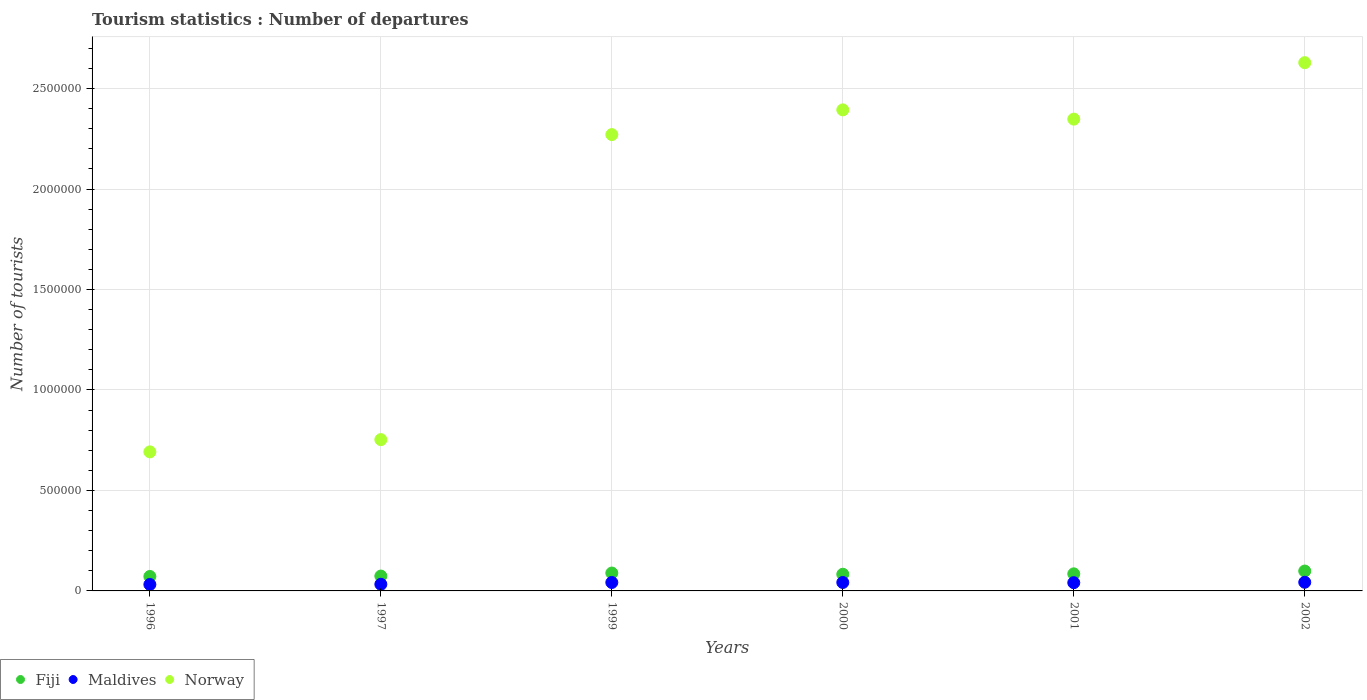Is the number of dotlines equal to the number of legend labels?
Give a very brief answer. Yes. What is the number of tourist departures in Maldives in 2000?
Make the answer very short. 4.20e+04. Across all years, what is the maximum number of tourist departures in Maldives?
Offer a terse response. 4.30e+04. Across all years, what is the minimum number of tourist departures in Norway?
Provide a short and direct response. 6.92e+05. What is the total number of tourist departures in Fiji in the graph?
Make the answer very short. 5.02e+05. What is the difference between the number of tourist departures in Maldives in 1996 and that in 2002?
Your answer should be very brief. -1.10e+04. What is the difference between the number of tourist departures in Fiji in 1999 and the number of tourist departures in Maldives in 2000?
Make the answer very short. 4.70e+04. What is the average number of tourist departures in Maldives per year?
Give a very brief answer. 3.88e+04. In the year 2002, what is the difference between the number of tourist departures in Fiji and number of tourist departures in Norway?
Ensure brevity in your answer.  -2.53e+06. What is the ratio of the number of tourist departures in Norway in 1997 to that in 2000?
Provide a short and direct response. 0.31. Is the difference between the number of tourist departures in Fiji in 1999 and 2002 greater than the difference between the number of tourist departures in Norway in 1999 and 2002?
Your answer should be very brief. Yes. What is the difference between the highest and the lowest number of tourist departures in Maldives?
Offer a very short reply. 1.10e+04. Is it the case that in every year, the sum of the number of tourist departures in Maldives and number of tourist departures in Fiji  is greater than the number of tourist departures in Norway?
Your answer should be compact. No. Is the number of tourist departures in Maldives strictly less than the number of tourist departures in Fiji over the years?
Your response must be concise. Yes. How many dotlines are there?
Offer a very short reply. 3. How many years are there in the graph?
Give a very brief answer. 6. Does the graph contain grids?
Your response must be concise. Yes. What is the title of the graph?
Provide a short and direct response. Tourism statistics : Number of departures. What is the label or title of the Y-axis?
Your response must be concise. Number of tourists. What is the Number of tourists in Fiji in 1996?
Offer a very short reply. 7.20e+04. What is the Number of tourists of Maldives in 1996?
Keep it short and to the point. 3.20e+04. What is the Number of tourists of Norway in 1996?
Provide a short and direct response. 6.92e+05. What is the Number of tourists of Fiji in 1997?
Offer a terse response. 7.40e+04. What is the Number of tourists of Maldives in 1997?
Your response must be concise. 3.30e+04. What is the Number of tourists in Norway in 1997?
Provide a short and direct response. 7.53e+05. What is the Number of tourists in Fiji in 1999?
Provide a succinct answer. 8.90e+04. What is the Number of tourists of Maldives in 1999?
Your answer should be very brief. 4.20e+04. What is the Number of tourists in Norway in 1999?
Make the answer very short. 2.27e+06. What is the Number of tourists in Fiji in 2000?
Provide a short and direct response. 8.30e+04. What is the Number of tourists of Maldives in 2000?
Make the answer very short. 4.20e+04. What is the Number of tourists of Norway in 2000?
Offer a very short reply. 2.39e+06. What is the Number of tourists in Fiji in 2001?
Ensure brevity in your answer.  8.50e+04. What is the Number of tourists in Maldives in 2001?
Ensure brevity in your answer.  4.10e+04. What is the Number of tourists in Norway in 2001?
Your response must be concise. 2.35e+06. What is the Number of tourists in Fiji in 2002?
Make the answer very short. 9.90e+04. What is the Number of tourists of Maldives in 2002?
Offer a very short reply. 4.30e+04. What is the Number of tourists in Norway in 2002?
Your answer should be very brief. 2.63e+06. Across all years, what is the maximum Number of tourists in Fiji?
Provide a succinct answer. 9.90e+04. Across all years, what is the maximum Number of tourists of Maldives?
Keep it short and to the point. 4.30e+04. Across all years, what is the maximum Number of tourists of Norway?
Keep it short and to the point. 2.63e+06. Across all years, what is the minimum Number of tourists in Fiji?
Your answer should be very brief. 7.20e+04. Across all years, what is the minimum Number of tourists of Maldives?
Give a very brief answer. 3.20e+04. Across all years, what is the minimum Number of tourists of Norway?
Provide a succinct answer. 6.92e+05. What is the total Number of tourists in Fiji in the graph?
Keep it short and to the point. 5.02e+05. What is the total Number of tourists in Maldives in the graph?
Ensure brevity in your answer.  2.33e+05. What is the total Number of tourists in Norway in the graph?
Keep it short and to the point. 1.11e+07. What is the difference between the Number of tourists of Fiji in 1996 and that in 1997?
Your response must be concise. -2000. What is the difference between the Number of tourists in Maldives in 1996 and that in 1997?
Keep it short and to the point. -1000. What is the difference between the Number of tourists of Norway in 1996 and that in 1997?
Provide a short and direct response. -6.10e+04. What is the difference between the Number of tourists in Fiji in 1996 and that in 1999?
Offer a terse response. -1.70e+04. What is the difference between the Number of tourists of Maldives in 1996 and that in 1999?
Offer a terse response. -10000. What is the difference between the Number of tourists in Norway in 1996 and that in 1999?
Your answer should be very brief. -1.58e+06. What is the difference between the Number of tourists in Fiji in 1996 and that in 2000?
Your response must be concise. -1.10e+04. What is the difference between the Number of tourists of Norway in 1996 and that in 2000?
Keep it short and to the point. -1.70e+06. What is the difference between the Number of tourists of Fiji in 1996 and that in 2001?
Your answer should be compact. -1.30e+04. What is the difference between the Number of tourists of Maldives in 1996 and that in 2001?
Your answer should be compact. -9000. What is the difference between the Number of tourists of Norway in 1996 and that in 2001?
Offer a very short reply. -1.66e+06. What is the difference between the Number of tourists in Fiji in 1996 and that in 2002?
Your response must be concise. -2.70e+04. What is the difference between the Number of tourists of Maldives in 1996 and that in 2002?
Offer a very short reply. -1.10e+04. What is the difference between the Number of tourists of Norway in 1996 and that in 2002?
Provide a succinct answer. -1.94e+06. What is the difference between the Number of tourists in Fiji in 1997 and that in 1999?
Keep it short and to the point. -1.50e+04. What is the difference between the Number of tourists of Maldives in 1997 and that in 1999?
Offer a very short reply. -9000. What is the difference between the Number of tourists of Norway in 1997 and that in 1999?
Ensure brevity in your answer.  -1.52e+06. What is the difference between the Number of tourists of Fiji in 1997 and that in 2000?
Provide a succinct answer. -9000. What is the difference between the Number of tourists in Maldives in 1997 and that in 2000?
Provide a succinct answer. -9000. What is the difference between the Number of tourists in Norway in 1997 and that in 2000?
Provide a short and direct response. -1.64e+06. What is the difference between the Number of tourists in Fiji in 1997 and that in 2001?
Provide a succinct answer. -1.10e+04. What is the difference between the Number of tourists of Maldives in 1997 and that in 2001?
Offer a terse response. -8000. What is the difference between the Number of tourists of Norway in 1997 and that in 2001?
Give a very brief answer. -1.60e+06. What is the difference between the Number of tourists of Fiji in 1997 and that in 2002?
Provide a short and direct response. -2.50e+04. What is the difference between the Number of tourists in Norway in 1997 and that in 2002?
Ensure brevity in your answer.  -1.88e+06. What is the difference between the Number of tourists of Fiji in 1999 and that in 2000?
Make the answer very short. 6000. What is the difference between the Number of tourists of Maldives in 1999 and that in 2000?
Provide a short and direct response. 0. What is the difference between the Number of tourists in Norway in 1999 and that in 2000?
Your answer should be compact. -1.23e+05. What is the difference between the Number of tourists in Fiji in 1999 and that in 2001?
Ensure brevity in your answer.  4000. What is the difference between the Number of tourists of Maldives in 1999 and that in 2001?
Ensure brevity in your answer.  1000. What is the difference between the Number of tourists of Norway in 1999 and that in 2001?
Provide a succinct answer. -7.70e+04. What is the difference between the Number of tourists in Maldives in 1999 and that in 2002?
Provide a succinct answer. -1000. What is the difference between the Number of tourists in Norway in 1999 and that in 2002?
Provide a short and direct response. -3.58e+05. What is the difference between the Number of tourists of Fiji in 2000 and that in 2001?
Provide a succinct answer. -2000. What is the difference between the Number of tourists of Norway in 2000 and that in 2001?
Offer a terse response. 4.60e+04. What is the difference between the Number of tourists of Fiji in 2000 and that in 2002?
Keep it short and to the point. -1.60e+04. What is the difference between the Number of tourists in Maldives in 2000 and that in 2002?
Offer a terse response. -1000. What is the difference between the Number of tourists in Norway in 2000 and that in 2002?
Provide a succinct answer. -2.35e+05. What is the difference between the Number of tourists of Fiji in 2001 and that in 2002?
Keep it short and to the point. -1.40e+04. What is the difference between the Number of tourists in Maldives in 2001 and that in 2002?
Ensure brevity in your answer.  -2000. What is the difference between the Number of tourists of Norway in 2001 and that in 2002?
Provide a succinct answer. -2.81e+05. What is the difference between the Number of tourists in Fiji in 1996 and the Number of tourists in Maldives in 1997?
Your answer should be compact. 3.90e+04. What is the difference between the Number of tourists of Fiji in 1996 and the Number of tourists of Norway in 1997?
Your answer should be very brief. -6.81e+05. What is the difference between the Number of tourists in Maldives in 1996 and the Number of tourists in Norway in 1997?
Make the answer very short. -7.21e+05. What is the difference between the Number of tourists of Fiji in 1996 and the Number of tourists of Maldives in 1999?
Provide a short and direct response. 3.00e+04. What is the difference between the Number of tourists in Fiji in 1996 and the Number of tourists in Norway in 1999?
Provide a succinct answer. -2.20e+06. What is the difference between the Number of tourists of Maldives in 1996 and the Number of tourists of Norway in 1999?
Your response must be concise. -2.24e+06. What is the difference between the Number of tourists of Fiji in 1996 and the Number of tourists of Maldives in 2000?
Your response must be concise. 3.00e+04. What is the difference between the Number of tourists of Fiji in 1996 and the Number of tourists of Norway in 2000?
Your response must be concise. -2.32e+06. What is the difference between the Number of tourists in Maldives in 1996 and the Number of tourists in Norway in 2000?
Keep it short and to the point. -2.36e+06. What is the difference between the Number of tourists of Fiji in 1996 and the Number of tourists of Maldives in 2001?
Your response must be concise. 3.10e+04. What is the difference between the Number of tourists in Fiji in 1996 and the Number of tourists in Norway in 2001?
Keep it short and to the point. -2.28e+06. What is the difference between the Number of tourists of Maldives in 1996 and the Number of tourists of Norway in 2001?
Your response must be concise. -2.32e+06. What is the difference between the Number of tourists of Fiji in 1996 and the Number of tourists of Maldives in 2002?
Provide a succinct answer. 2.90e+04. What is the difference between the Number of tourists in Fiji in 1996 and the Number of tourists in Norway in 2002?
Offer a very short reply. -2.56e+06. What is the difference between the Number of tourists in Maldives in 1996 and the Number of tourists in Norway in 2002?
Your response must be concise. -2.60e+06. What is the difference between the Number of tourists in Fiji in 1997 and the Number of tourists in Maldives in 1999?
Your answer should be compact. 3.20e+04. What is the difference between the Number of tourists in Fiji in 1997 and the Number of tourists in Norway in 1999?
Keep it short and to the point. -2.20e+06. What is the difference between the Number of tourists in Maldives in 1997 and the Number of tourists in Norway in 1999?
Offer a terse response. -2.24e+06. What is the difference between the Number of tourists of Fiji in 1997 and the Number of tourists of Maldives in 2000?
Offer a terse response. 3.20e+04. What is the difference between the Number of tourists of Fiji in 1997 and the Number of tourists of Norway in 2000?
Provide a short and direct response. -2.32e+06. What is the difference between the Number of tourists of Maldives in 1997 and the Number of tourists of Norway in 2000?
Provide a short and direct response. -2.36e+06. What is the difference between the Number of tourists of Fiji in 1997 and the Number of tourists of Maldives in 2001?
Keep it short and to the point. 3.30e+04. What is the difference between the Number of tourists of Fiji in 1997 and the Number of tourists of Norway in 2001?
Your answer should be very brief. -2.27e+06. What is the difference between the Number of tourists of Maldives in 1997 and the Number of tourists of Norway in 2001?
Your answer should be compact. -2.32e+06. What is the difference between the Number of tourists in Fiji in 1997 and the Number of tourists in Maldives in 2002?
Your answer should be very brief. 3.10e+04. What is the difference between the Number of tourists in Fiji in 1997 and the Number of tourists in Norway in 2002?
Give a very brief answer. -2.56e+06. What is the difference between the Number of tourists in Maldives in 1997 and the Number of tourists in Norway in 2002?
Give a very brief answer. -2.60e+06. What is the difference between the Number of tourists in Fiji in 1999 and the Number of tourists in Maldives in 2000?
Ensure brevity in your answer.  4.70e+04. What is the difference between the Number of tourists of Fiji in 1999 and the Number of tourists of Norway in 2000?
Offer a very short reply. -2.30e+06. What is the difference between the Number of tourists of Maldives in 1999 and the Number of tourists of Norway in 2000?
Your response must be concise. -2.35e+06. What is the difference between the Number of tourists of Fiji in 1999 and the Number of tourists of Maldives in 2001?
Your answer should be very brief. 4.80e+04. What is the difference between the Number of tourists in Fiji in 1999 and the Number of tourists in Norway in 2001?
Provide a short and direct response. -2.26e+06. What is the difference between the Number of tourists of Maldives in 1999 and the Number of tourists of Norway in 2001?
Provide a short and direct response. -2.31e+06. What is the difference between the Number of tourists of Fiji in 1999 and the Number of tourists of Maldives in 2002?
Ensure brevity in your answer.  4.60e+04. What is the difference between the Number of tourists of Fiji in 1999 and the Number of tourists of Norway in 2002?
Keep it short and to the point. -2.54e+06. What is the difference between the Number of tourists of Maldives in 1999 and the Number of tourists of Norway in 2002?
Make the answer very short. -2.59e+06. What is the difference between the Number of tourists in Fiji in 2000 and the Number of tourists in Maldives in 2001?
Your answer should be very brief. 4.20e+04. What is the difference between the Number of tourists of Fiji in 2000 and the Number of tourists of Norway in 2001?
Keep it short and to the point. -2.26e+06. What is the difference between the Number of tourists of Maldives in 2000 and the Number of tourists of Norway in 2001?
Offer a very short reply. -2.31e+06. What is the difference between the Number of tourists in Fiji in 2000 and the Number of tourists in Maldives in 2002?
Keep it short and to the point. 4.00e+04. What is the difference between the Number of tourists of Fiji in 2000 and the Number of tourists of Norway in 2002?
Provide a short and direct response. -2.55e+06. What is the difference between the Number of tourists in Maldives in 2000 and the Number of tourists in Norway in 2002?
Offer a very short reply. -2.59e+06. What is the difference between the Number of tourists of Fiji in 2001 and the Number of tourists of Maldives in 2002?
Your response must be concise. 4.20e+04. What is the difference between the Number of tourists in Fiji in 2001 and the Number of tourists in Norway in 2002?
Offer a terse response. -2.54e+06. What is the difference between the Number of tourists in Maldives in 2001 and the Number of tourists in Norway in 2002?
Offer a very short reply. -2.59e+06. What is the average Number of tourists in Fiji per year?
Offer a terse response. 8.37e+04. What is the average Number of tourists in Maldives per year?
Provide a short and direct response. 3.88e+04. What is the average Number of tourists of Norway per year?
Your response must be concise. 1.85e+06. In the year 1996, what is the difference between the Number of tourists in Fiji and Number of tourists in Norway?
Provide a succinct answer. -6.20e+05. In the year 1996, what is the difference between the Number of tourists in Maldives and Number of tourists in Norway?
Offer a terse response. -6.60e+05. In the year 1997, what is the difference between the Number of tourists in Fiji and Number of tourists in Maldives?
Your response must be concise. 4.10e+04. In the year 1997, what is the difference between the Number of tourists in Fiji and Number of tourists in Norway?
Make the answer very short. -6.79e+05. In the year 1997, what is the difference between the Number of tourists of Maldives and Number of tourists of Norway?
Keep it short and to the point. -7.20e+05. In the year 1999, what is the difference between the Number of tourists of Fiji and Number of tourists of Maldives?
Give a very brief answer. 4.70e+04. In the year 1999, what is the difference between the Number of tourists of Fiji and Number of tourists of Norway?
Make the answer very short. -2.18e+06. In the year 1999, what is the difference between the Number of tourists of Maldives and Number of tourists of Norway?
Provide a succinct answer. -2.23e+06. In the year 2000, what is the difference between the Number of tourists in Fiji and Number of tourists in Maldives?
Keep it short and to the point. 4.10e+04. In the year 2000, what is the difference between the Number of tourists of Fiji and Number of tourists of Norway?
Offer a very short reply. -2.31e+06. In the year 2000, what is the difference between the Number of tourists of Maldives and Number of tourists of Norway?
Your answer should be very brief. -2.35e+06. In the year 2001, what is the difference between the Number of tourists in Fiji and Number of tourists in Maldives?
Your answer should be compact. 4.40e+04. In the year 2001, what is the difference between the Number of tourists in Fiji and Number of tourists in Norway?
Offer a very short reply. -2.26e+06. In the year 2001, what is the difference between the Number of tourists of Maldives and Number of tourists of Norway?
Offer a terse response. -2.31e+06. In the year 2002, what is the difference between the Number of tourists in Fiji and Number of tourists in Maldives?
Your response must be concise. 5.60e+04. In the year 2002, what is the difference between the Number of tourists of Fiji and Number of tourists of Norway?
Give a very brief answer. -2.53e+06. In the year 2002, what is the difference between the Number of tourists in Maldives and Number of tourists in Norway?
Your answer should be very brief. -2.59e+06. What is the ratio of the Number of tourists in Maldives in 1996 to that in 1997?
Your response must be concise. 0.97. What is the ratio of the Number of tourists of Norway in 1996 to that in 1997?
Offer a very short reply. 0.92. What is the ratio of the Number of tourists in Fiji in 1996 to that in 1999?
Offer a very short reply. 0.81. What is the ratio of the Number of tourists in Maldives in 1996 to that in 1999?
Your response must be concise. 0.76. What is the ratio of the Number of tourists of Norway in 1996 to that in 1999?
Your response must be concise. 0.3. What is the ratio of the Number of tourists in Fiji in 1996 to that in 2000?
Offer a very short reply. 0.87. What is the ratio of the Number of tourists in Maldives in 1996 to that in 2000?
Provide a short and direct response. 0.76. What is the ratio of the Number of tourists of Norway in 1996 to that in 2000?
Provide a short and direct response. 0.29. What is the ratio of the Number of tourists of Fiji in 1996 to that in 2001?
Offer a terse response. 0.85. What is the ratio of the Number of tourists of Maldives in 1996 to that in 2001?
Offer a terse response. 0.78. What is the ratio of the Number of tourists of Norway in 1996 to that in 2001?
Give a very brief answer. 0.29. What is the ratio of the Number of tourists in Fiji in 1996 to that in 2002?
Ensure brevity in your answer.  0.73. What is the ratio of the Number of tourists in Maldives in 1996 to that in 2002?
Keep it short and to the point. 0.74. What is the ratio of the Number of tourists in Norway in 1996 to that in 2002?
Your answer should be compact. 0.26. What is the ratio of the Number of tourists in Fiji in 1997 to that in 1999?
Give a very brief answer. 0.83. What is the ratio of the Number of tourists in Maldives in 1997 to that in 1999?
Give a very brief answer. 0.79. What is the ratio of the Number of tourists of Norway in 1997 to that in 1999?
Keep it short and to the point. 0.33. What is the ratio of the Number of tourists in Fiji in 1997 to that in 2000?
Your answer should be compact. 0.89. What is the ratio of the Number of tourists of Maldives in 1997 to that in 2000?
Your answer should be very brief. 0.79. What is the ratio of the Number of tourists of Norway in 1997 to that in 2000?
Your answer should be very brief. 0.31. What is the ratio of the Number of tourists in Fiji in 1997 to that in 2001?
Your response must be concise. 0.87. What is the ratio of the Number of tourists of Maldives in 1997 to that in 2001?
Ensure brevity in your answer.  0.8. What is the ratio of the Number of tourists of Norway in 1997 to that in 2001?
Make the answer very short. 0.32. What is the ratio of the Number of tourists of Fiji in 1997 to that in 2002?
Keep it short and to the point. 0.75. What is the ratio of the Number of tourists of Maldives in 1997 to that in 2002?
Offer a terse response. 0.77. What is the ratio of the Number of tourists of Norway in 1997 to that in 2002?
Give a very brief answer. 0.29. What is the ratio of the Number of tourists in Fiji in 1999 to that in 2000?
Make the answer very short. 1.07. What is the ratio of the Number of tourists in Maldives in 1999 to that in 2000?
Your response must be concise. 1. What is the ratio of the Number of tourists of Norway in 1999 to that in 2000?
Your answer should be very brief. 0.95. What is the ratio of the Number of tourists in Fiji in 1999 to that in 2001?
Offer a very short reply. 1.05. What is the ratio of the Number of tourists in Maldives in 1999 to that in 2001?
Make the answer very short. 1.02. What is the ratio of the Number of tourists in Norway in 1999 to that in 2001?
Your answer should be very brief. 0.97. What is the ratio of the Number of tourists of Fiji in 1999 to that in 2002?
Make the answer very short. 0.9. What is the ratio of the Number of tourists in Maldives in 1999 to that in 2002?
Your answer should be very brief. 0.98. What is the ratio of the Number of tourists in Norway in 1999 to that in 2002?
Keep it short and to the point. 0.86. What is the ratio of the Number of tourists in Fiji in 2000 to that in 2001?
Your answer should be compact. 0.98. What is the ratio of the Number of tourists of Maldives in 2000 to that in 2001?
Provide a short and direct response. 1.02. What is the ratio of the Number of tourists of Norway in 2000 to that in 2001?
Keep it short and to the point. 1.02. What is the ratio of the Number of tourists of Fiji in 2000 to that in 2002?
Provide a succinct answer. 0.84. What is the ratio of the Number of tourists of Maldives in 2000 to that in 2002?
Provide a short and direct response. 0.98. What is the ratio of the Number of tourists of Norway in 2000 to that in 2002?
Your answer should be compact. 0.91. What is the ratio of the Number of tourists in Fiji in 2001 to that in 2002?
Provide a succinct answer. 0.86. What is the ratio of the Number of tourists in Maldives in 2001 to that in 2002?
Keep it short and to the point. 0.95. What is the ratio of the Number of tourists in Norway in 2001 to that in 2002?
Give a very brief answer. 0.89. What is the difference between the highest and the second highest Number of tourists of Maldives?
Offer a very short reply. 1000. What is the difference between the highest and the second highest Number of tourists of Norway?
Give a very brief answer. 2.35e+05. What is the difference between the highest and the lowest Number of tourists in Fiji?
Your answer should be compact. 2.70e+04. What is the difference between the highest and the lowest Number of tourists of Maldives?
Your answer should be compact. 1.10e+04. What is the difference between the highest and the lowest Number of tourists of Norway?
Ensure brevity in your answer.  1.94e+06. 